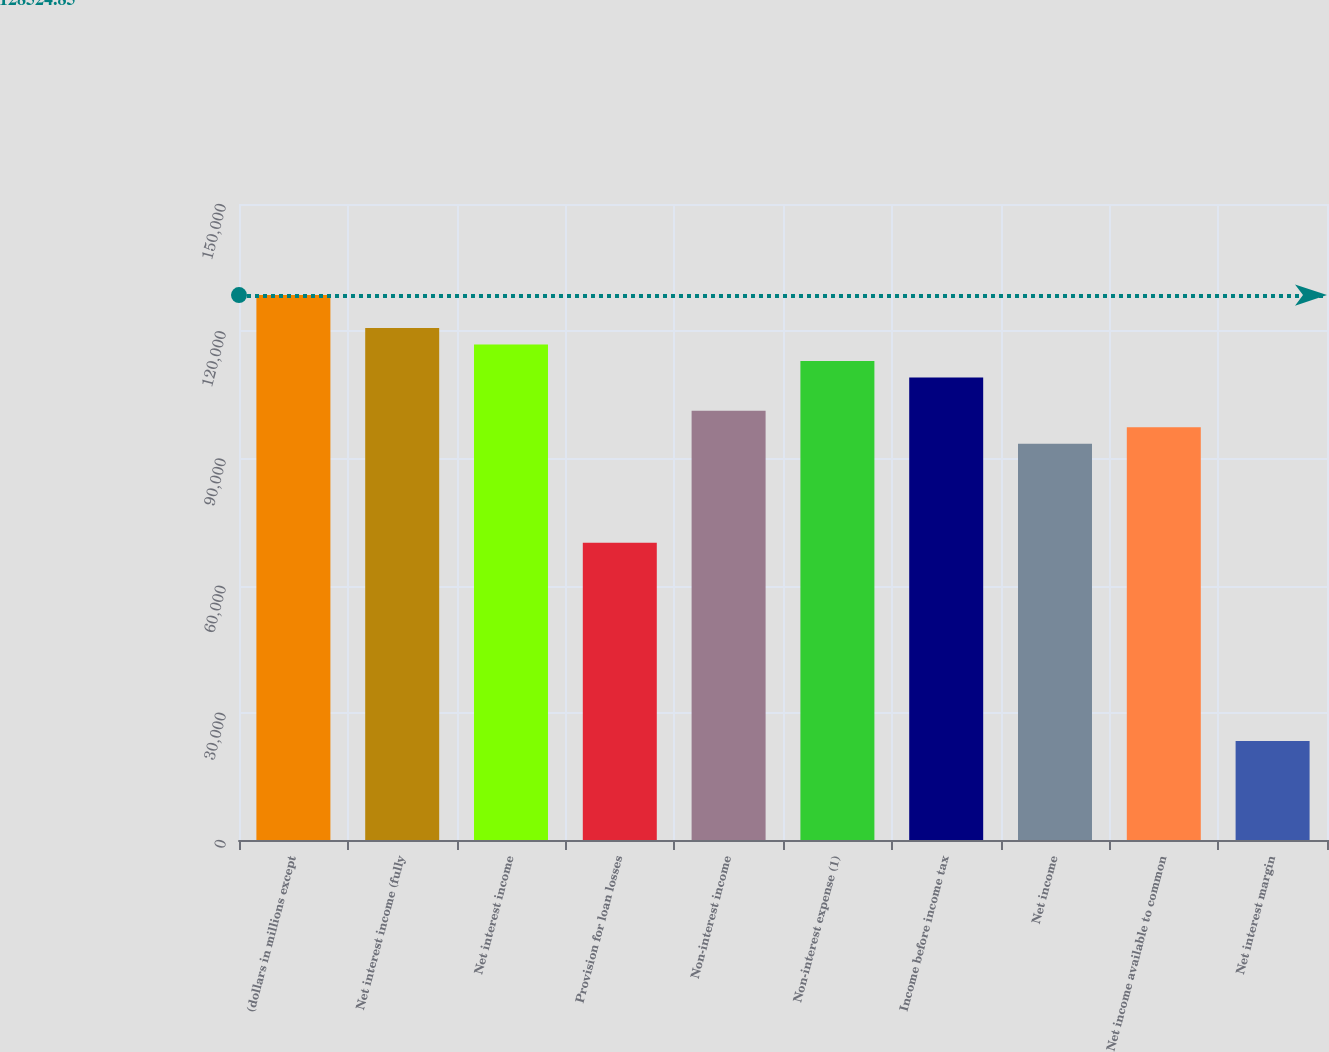<chart> <loc_0><loc_0><loc_500><loc_500><bar_chart><fcel>(dollars in millions except<fcel>Net interest income (fully<fcel>Net interest income<fcel>Provision for loan losses<fcel>Non-interest income<fcel>Non-interest expense (1)<fcel>Income before income tax<fcel>Net income<fcel>Net income available to common<fcel>Net interest margin<nl><fcel>128525<fcel>120735<fcel>116841<fcel>70104.5<fcel>101262<fcel>112946<fcel>109051<fcel>93472.6<fcel>97367.3<fcel>23368.2<nl></chart> 